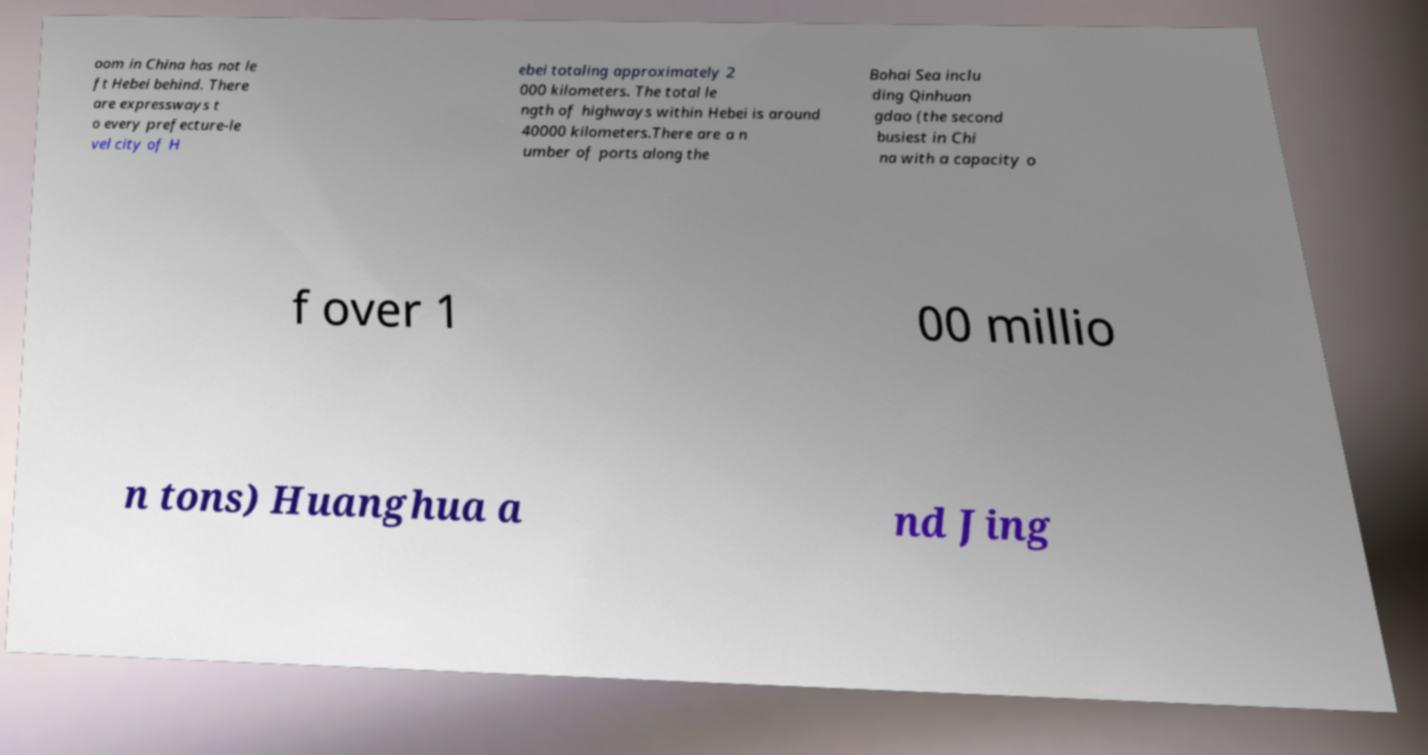Could you extract and type out the text from this image? oom in China has not le ft Hebei behind. There are expressways t o every prefecture-le vel city of H ebei totaling approximately 2 000 kilometers. The total le ngth of highways within Hebei is around 40000 kilometers.There are a n umber of ports along the Bohai Sea inclu ding Qinhuan gdao (the second busiest in Chi na with a capacity o f over 1 00 millio n tons) Huanghua a nd Jing 